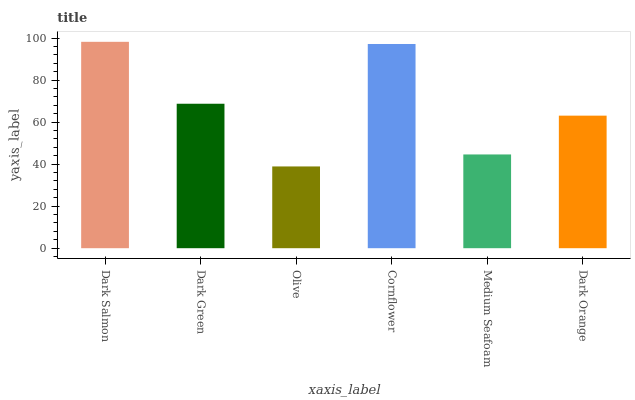Is Olive the minimum?
Answer yes or no. Yes. Is Dark Salmon the maximum?
Answer yes or no. Yes. Is Dark Green the minimum?
Answer yes or no. No. Is Dark Green the maximum?
Answer yes or no. No. Is Dark Salmon greater than Dark Green?
Answer yes or no. Yes. Is Dark Green less than Dark Salmon?
Answer yes or no. Yes. Is Dark Green greater than Dark Salmon?
Answer yes or no. No. Is Dark Salmon less than Dark Green?
Answer yes or no. No. Is Dark Green the high median?
Answer yes or no. Yes. Is Dark Orange the low median?
Answer yes or no. Yes. Is Dark Salmon the high median?
Answer yes or no. No. Is Medium Seafoam the low median?
Answer yes or no. No. 